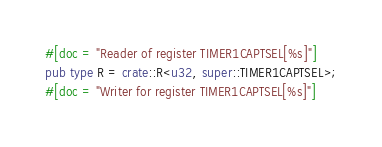Convert code to text. <code><loc_0><loc_0><loc_500><loc_500><_Rust_>#[doc = "Reader of register TIMER1CAPTSEL[%s]"]
pub type R = crate::R<u32, super::TIMER1CAPTSEL>;
#[doc = "Writer for register TIMER1CAPTSEL[%s]"]</code> 